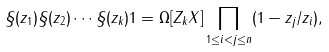<formula> <loc_0><loc_0><loc_500><loc_500>\S ( z _ { 1 } ) \S ( z _ { 2 } ) \cdots \S ( z _ { k } ) 1 = \Omega [ Z _ { k } X ] \prod _ { 1 \leq i < j \leq n } ( 1 - z _ { j } / z _ { i } ) ,</formula> 